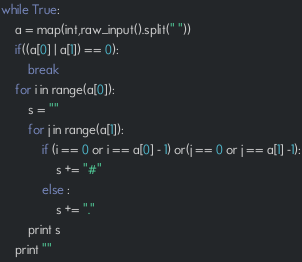<code> <loc_0><loc_0><loc_500><loc_500><_Python_>while True:
    a = map(int,raw_input().split(" "))
    if((a[0] | a[1]) == 0):
        break
    for i in range(a[0]):
        s = ""
        for j in range(a[1]):
            if (i == 0 or i == a[0] - 1) or(j == 0 or j == a[1] -1):
                s += "#"
            else :
                s += "."
        print s
    print ""</code> 